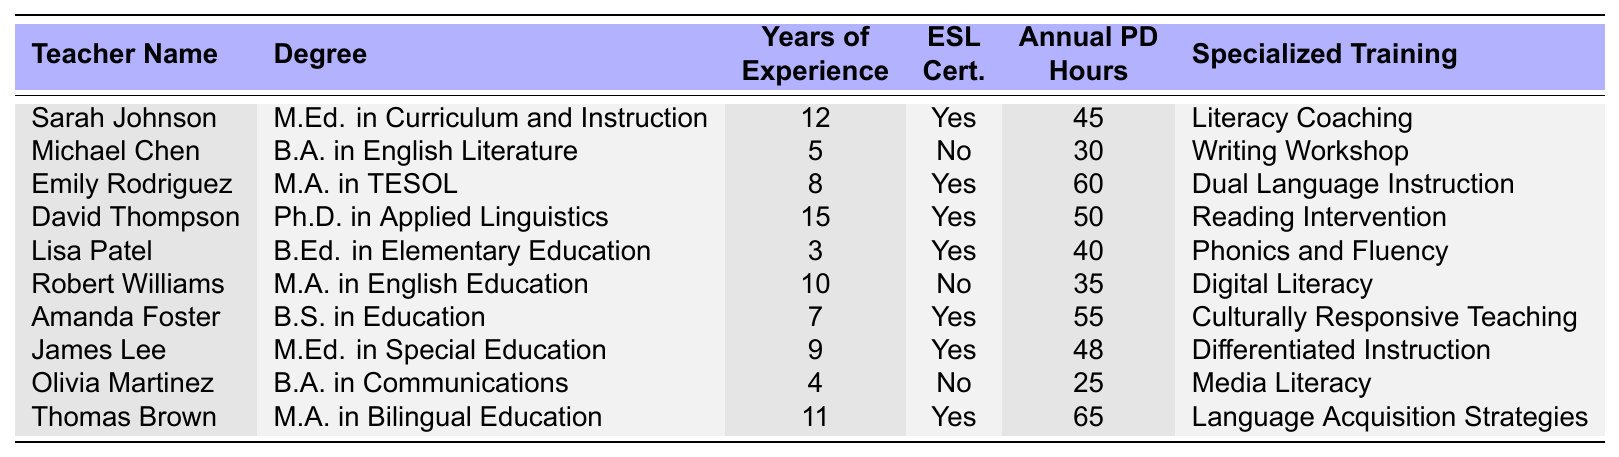What is the highest degree obtained by a teacher in this table? The table shows various degrees held by teachers. By scanning through the "Degree" column, the highest degree is the "Ph.D. in Applied Linguistics" held by David Thompson.
Answer: Ph.D. in Applied Linguistics How many teachers in the table have ESL Certification? I will look at the "ESL Cert." column and count the number of "Yes" entries. There are 6 teachers with ESL Certification: Sarah Johnson, Emily Rodriguez, David Thompson, Lisa Patel, Amanda Foster, and James Lee.
Answer: 6 What is the average annual professional development hours in English instruction for the teachers listed? I add the values of all the "Annual PD Hours" (45 + 30 + 60 + 50 + 40 + 35 + 55 + 48 + 25 + 65 =  448) and divide by the total number of teachers (10). The average is 448/10 = 44.8.
Answer: 44.8 Which teacher has the most years of experience? I will check the "Years of Experience" column to find the maximum value, which is 15 years by David Thompson.
Answer: David Thompson What percentage of teachers have specialized training in the table? There are 10 teachers total, and all but one (Michael Chen) have specialized training. That is 9 out of 10, so the percentage is (9/10)*100 = 90%.
Answer: 90% Is there a teacher with both ESL Certification and the least number of annual PD hours? I need to find the teacher with the least number of annual PD hours who also has ESL Certification. The teacher with the least PD hours is Lisa Patel (40 hours) and she has an ESL Certification.
Answer: Yes What is the difference in annual PD hours between the teacher with the most experience and the one with the least? The most experienced teacher is David Thompson with 50 hours, the least is Olivia Martinez with 25 hours. The difference is 50 - 25 = 25.
Answer: 25 Which teacher has the most specialized training hours in the table? The "Specialized Training" section does not provide specific hours, so I check the context of trainings and find Thomas Brown's "Language Acquisition Strategies" and Emily Rodriguez's "Dual Language Instruction" appear comprehensive, but no direct hours are listed. All specialized training descriptions seem equally intensive.
Answer: Cannot determine exact specialized training hours What is the total number of years of experience among all the teachers listed? I will sum up all the years of experience: (12 + 5 + 8 + 15 + 3 + 10 + 7 + 9 + 4 + 11 =  70). The total is 70 years.
Answer: 70 Are there any teachers without ESL Certification who have more than 30 PD hours? I check the "ESL Cert." column and find that Robert Williams (35 hours) and Michael Chen (30 hours) do not hold ESL Certification. Both have more than 30 PD hours.
Answer: Yes 